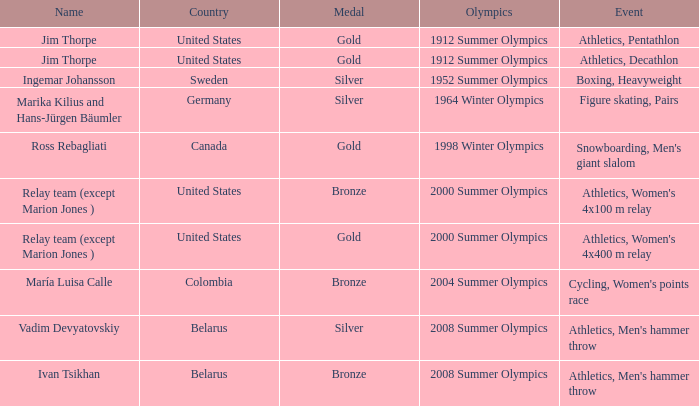Write the full table. {'header': ['Name', 'Country', 'Medal', 'Olympics', 'Event'], 'rows': [['Jim Thorpe', 'United States', 'Gold', '1912 Summer Olympics', 'Athletics, Pentathlon'], ['Jim Thorpe', 'United States', 'Gold', '1912 Summer Olympics', 'Athletics, Decathlon'], ['Ingemar Johansson', 'Sweden', 'Silver', '1952 Summer Olympics', 'Boxing, Heavyweight'], ['Marika Kilius and Hans-Jürgen Bäumler', 'Germany', 'Silver', '1964 Winter Olympics', 'Figure skating, Pairs'], ['Ross Rebagliati', 'Canada', 'Gold', '1998 Winter Olympics', "Snowboarding, Men's giant slalom"], ['Relay team (except Marion Jones )', 'United States', 'Bronze', '2000 Summer Olympics', "Athletics, Women's 4x100 m relay"], ['Relay team (except Marion Jones )', 'United States', 'Gold', '2000 Summer Olympics', "Athletics, Women's 4x400 m relay"], ['María Luisa Calle', 'Colombia', 'Bronze', '2004 Summer Olympics', "Cycling, Women's points race"], ['Vadim Devyatovskiy', 'Belarus', 'Silver', '2008 Summer Olympics', "Athletics, Men's hammer throw"], ['Ivan Tsikhan', 'Belarus', 'Bronze', '2008 Summer Olympics', "Athletics, Men's hammer throw"]]} What is the event in the 2000 summer olympics with a bronze medal? Athletics, Women's 4x100 m relay. 